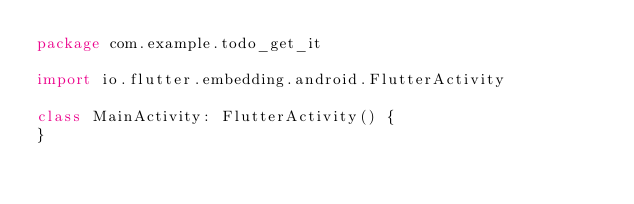Convert code to text. <code><loc_0><loc_0><loc_500><loc_500><_Kotlin_>package com.example.todo_get_it

import io.flutter.embedding.android.FlutterActivity

class MainActivity: FlutterActivity() {
}
</code> 